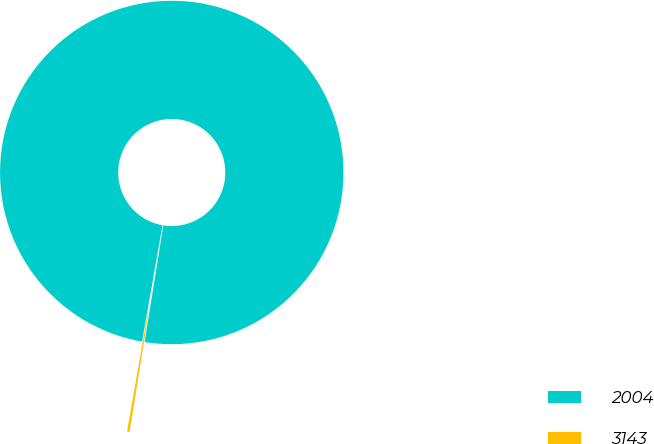Convert chart to OTSL. <chart><loc_0><loc_0><loc_500><loc_500><pie_chart><fcel>2004<fcel>3143<nl><fcel>99.76%<fcel>0.24%<nl></chart> 